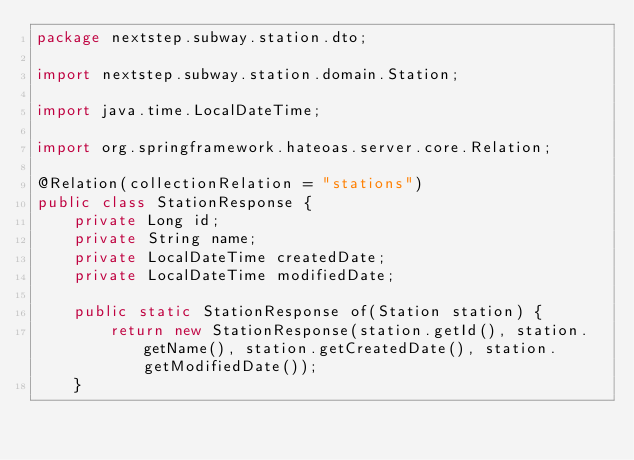<code> <loc_0><loc_0><loc_500><loc_500><_Java_>package nextstep.subway.station.dto;

import nextstep.subway.station.domain.Station;

import java.time.LocalDateTime;

import org.springframework.hateoas.server.core.Relation;

@Relation(collectionRelation = "stations")
public class StationResponse {
    private Long id;
    private String name;
    private LocalDateTime createdDate;
    private LocalDateTime modifiedDate;

    public static StationResponse of(Station station) {
        return new StationResponse(station.getId(), station.getName(), station.getCreatedDate(), station.getModifiedDate());
    }
</code> 